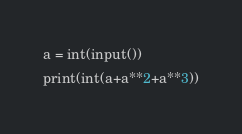<code> <loc_0><loc_0><loc_500><loc_500><_Python_>a = int(input())
print(int(a+a**2+a**3))</code> 